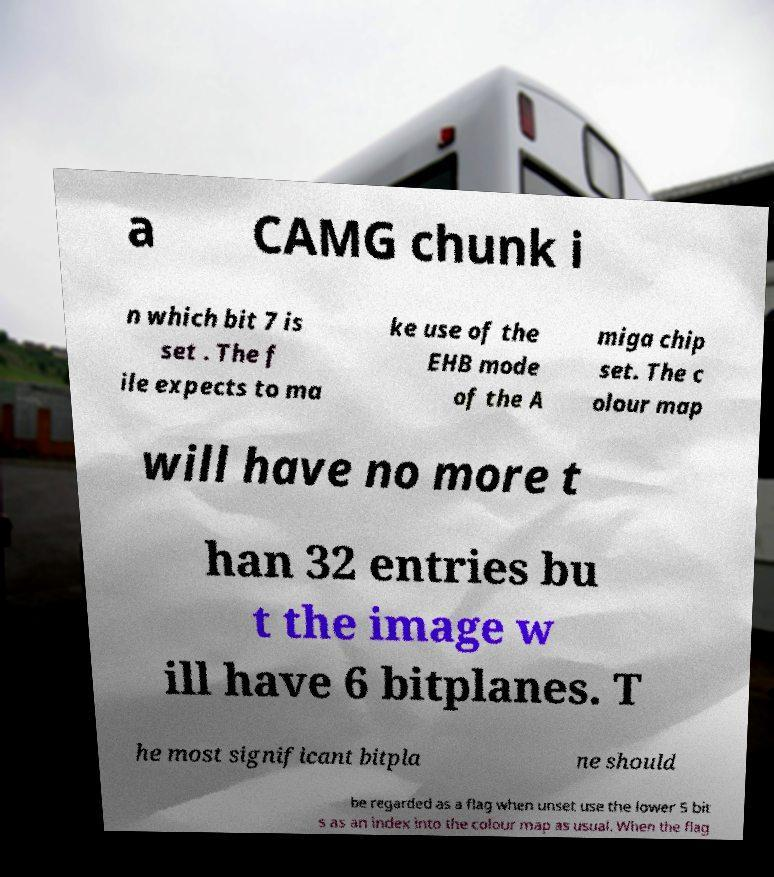Could you extract and type out the text from this image? a CAMG chunk i n which bit 7 is set . The f ile expects to ma ke use of the EHB mode of the A miga chip set. The c olour map will have no more t han 32 entries bu t the image w ill have 6 bitplanes. T he most significant bitpla ne should be regarded as a flag when unset use the lower 5 bit s as an index into the colour map as usual. When the flag 